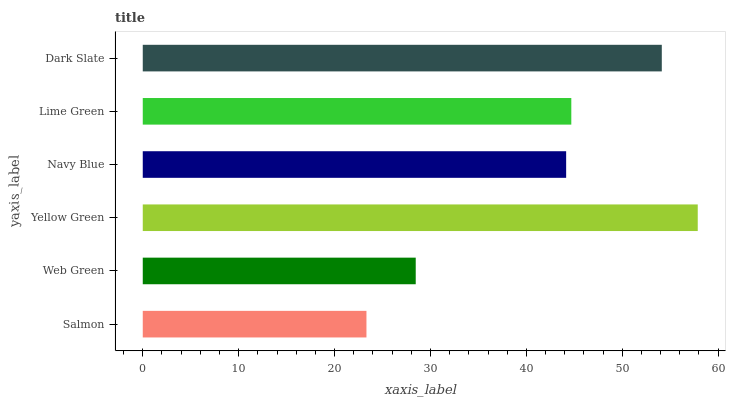Is Salmon the minimum?
Answer yes or no. Yes. Is Yellow Green the maximum?
Answer yes or no. Yes. Is Web Green the minimum?
Answer yes or no. No. Is Web Green the maximum?
Answer yes or no. No. Is Web Green greater than Salmon?
Answer yes or no. Yes. Is Salmon less than Web Green?
Answer yes or no. Yes. Is Salmon greater than Web Green?
Answer yes or no. No. Is Web Green less than Salmon?
Answer yes or no. No. Is Lime Green the high median?
Answer yes or no. Yes. Is Navy Blue the low median?
Answer yes or no. Yes. Is Navy Blue the high median?
Answer yes or no. No. Is Lime Green the low median?
Answer yes or no. No. 